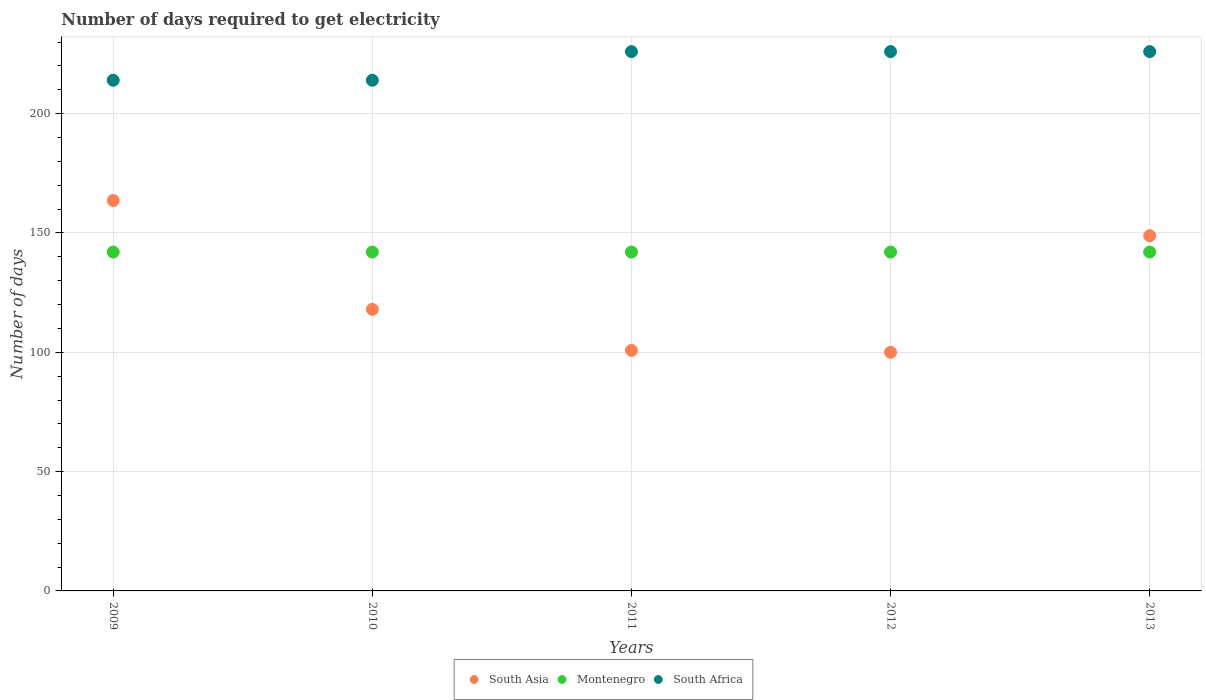How many different coloured dotlines are there?
Your response must be concise. 3. What is the number of days required to get electricity in in South Africa in 2011?
Give a very brief answer. 226. Across all years, what is the maximum number of days required to get electricity in in South Asia?
Offer a terse response. 163.6. Across all years, what is the minimum number of days required to get electricity in in South Asia?
Your answer should be compact. 100. In which year was the number of days required to get electricity in in Montenegro minimum?
Ensure brevity in your answer.  2009. What is the total number of days required to get electricity in in Montenegro in the graph?
Provide a succinct answer. 710. What is the difference between the number of days required to get electricity in in South Africa in 2011 and the number of days required to get electricity in in Montenegro in 2010?
Provide a succinct answer. 84. What is the average number of days required to get electricity in in South Asia per year?
Provide a succinct answer. 126.25. In the year 2012, what is the difference between the number of days required to get electricity in in South Africa and number of days required to get electricity in in Montenegro?
Offer a very short reply. 84. In how many years, is the number of days required to get electricity in in Montenegro greater than 150 days?
Ensure brevity in your answer.  0. What is the ratio of the number of days required to get electricity in in South Asia in 2009 to that in 2012?
Your answer should be compact. 1.64. Is the difference between the number of days required to get electricity in in South Africa in 2010 and 2012 greater than the difference between the number of days required to get electricity in in Montenegro in 2010 and 2012?
Offer a terse response. No. What is the difference between the highest and the lowest number of days required to get electricity in in South Asia?
Make the answer very short. 63.6. Is the sum of the number of days required to get electricity in in South Africa in 2009 and 2013 greater than the maximum number of days required to get electricity in in Montenegro across all years?
Make the answer very short. Yes. Is it the case that in every year, the sum of the number of days required to get electricity in in South Asia and number of days required to get electricity in in South Africa  is greater than the number of days required to get electricity in in Montenegro?
Offer a terse response. Yes. Is the number of days required to get electricity in in South Asia strictly greater than the number of days required to get electricity in in South Africa over the years?
Offer a very short reply. No. Is the number of days required to get electricity in in Montenegro strictly less than the number of days required to get electricity in in South Asia over the years?
Provide a succinct answer. No. How many dotlines are there?
Offer a terse response. 3. What is the difference between two consecutive major ticks on the Y-axis?
Provide a short and direct response. 50. Does the graph contain any zero values?
Ensure brevity in your answer.  No. Does the graph contain grids?
Ensure brevity in your answer.  Yes. How many legend labels are there?
Offer a terse response. 3. What is the title of the graph?
Give a very brief answer. Number of days required to get electricity. What is the label or title of the Y-axis?
Your response must be concise. Number of days. What is the Number of days of South Asia in 2009?
Make the answer very short. 163.6. What is the Number of days in Montenegro in 2009?
Provide a short and direct response. 142. What is the Number of days in South Africa in 2009?
Your answer should be compact. 214. What is the Number of days in South Asia in 2010?
Your answer should be compact. 118. What is the Number of days of Montenegro in 2010?
Your answer should be compact. 142. What is the Number of days of South Africa in 2010?
Give a very brief answer. 214. What is the Number of days in South Asia in 2011?
Provide a short and direct response. 100.8. What is the Number of days of Montenegro in 2011?
Provide a succinct answer. 142. What is the Number of days of South Africa in 2011?
Offer a terse response. 226. What is the Number of days in Montenegro in 2012?
Offer a terse response. 142. What is the Number of days in South Africa in 2012?
Keep it short and to the point. 226. What is the Number of days of South Asia in 2013?
Make the answer very short. 148.86. What is the Number of days in Montenegro in 2013?
Provide a short and direct response. 142. What is the Number of days of South Africa in 2013?
Your response must be concise. 226. Across all years, what is the maximum Number of days in South Asia?
Provide a succinct answer. 163.6. Across all years, what is the maximum Number of days in Montenegro?
Make the answer very short. 142. Across all years, what is the maximum Number of days in South Africa?
Give a very brief answer. 226. Across all years, what is the minimum Number of days of Montenegro?
Offer a very short reply. 142. Across all years, what is the minimum Number of days in South Africa?
Offer a terse response. 214. What is the total Number of days of South Asia in the graph?
Offer a terse response. 631.26. What is the total Number of days in Montenegro in the graph?
Your answer should be compact. 710. What is the total Number of days of South Africa in the graph?
Make the answer very short. 1106. What is the difference between the Number of days in South Asia in 2009 and that in 2010?
Ensure brevity in your answer.  45.6. What is the difference between the Number of days of South Asia in 2009 and that in 2011?
Your response must be concise. 62.8. What is the difference between the Number of days in Montenegro in 2009 and that in 2011?
Make the answer very short. 0. What is the difference between the Number of days of South Africa in 2009 and that in 2011?
Make the answer very short. -12. What is the difference between the Number of days in South Asia in 2009 and that in 2012?
Give a very brief answer. 63.6. What is the difference between the Number of days of South Africa in 2009 and that in 2012?
Offer a very short reply. -12. What is the difference between the Number of days in South Asia in 2009 and that in 2013?
Offer a terse response. 14.74. What is the difference between the Number of days in Montenegro in 2009 and that in 2013?
Your answer should be very brief. 0. What is the difference between the Number of days in South Africa in 2009 and that in 2013?
Your answer should be compact. -12. What is the difference between the Number of days of South Asia in 2010 and that in 2011?
Provide a short and direct response. 17.2. What is the difference between the Number of days of Montenegro in 2010 and that in 2011?
Keep it short and to the point. 0. What is the difference between the Number of days in South Africa in 2010 and that in 2011?
Ensure brevity in your answer.  -12. What is the difference between the Number of days in South Asia in 2010 and that in 2012?
Provide a short and direct response. 18. What is the difference between the Number of days of South Asia in 2010 and that in 2013?
Provide a succinct answer. -30.86. What is the difference between the Number of days of Montenegro in 2010 and that in 2013?
Make the answer very short. 0. What is the difference between the Number of days of South Asia in 2011 and that in 2012?
Give a very brief answer. 0.8. What is the difference between the Number of days in Montenegro in 2011 and that in 2012?
Offer a very short reply. 0. What is the difference between the Number of days in South Africa in 2011 and that in 2012?
Ensure brevity in your answer.  0. What is the difference between the Number of days of South Asia in 2011 and that in 2013?
Ensure brevity in your answer.  -48.06. What is the difference between the Number of days of South Asia in 2012 and that in 2013?
Make the answer very short. -48.86. What is the difference between the Number of days of South Asia in 2009 and the Number of days of Montenegro in 2010?
Your answer should be compact. 21.6. What is the difference between the Number of days of South Asia in 2009 and the Number of days of South Africa in 2010?
Your answer should be very brief. -50.4. What is the difference between the Number of days of Montenegro in 2009 and the Number of days of South Africa in 2010?
Your response must be concise. -72. What is the difference between the Number of days of South Asia in 2009 and the Number of days of Montenegro in 2011?
Offer a terse response. 21.6. What is the difference between the Number of days of South Asia in 2009 and the Number of days of South Africa in 2011?
Keep it short and to the point. -62.4. What is the difference between the Number of days of Montenegro in 2009 and the Number of days of South Africa in 2011?
Your answer should be very brief. -84. What is the difference between the Number of days of South Asia in 2009 and the Number of days of Montenegro in 2012?
Provide a short and direct response. 21.6. What is the difference between the Number of days in South Asia in 2009 and the Number of days in South Africa in 2012?
Give a very brief answer. -62.4. What is the difference between the Number of days in Montenegro in 2009 and the Number of days in South Africa in 2012?
Your response must be concise. -84. What is the difference between the Number of days in South Asia in 2009 and the Number of days in Montenegro in 2013?
Offer a very short reply. 21.6. What is the difference between the Number of days in South Asia in 2009 and the Number of days in South Africa in 2013?
Your response must be concise. -62.4. What is the difference between the Number of days of Montenegro in 2009 and the Number of days of South Africa in 2013?
Provide a succinct answer. -84. What is the difference between the Number of days in South Asia in 2010 and the Number of days in South Africa in 2011?
Offer a very short reply. -108. What is the difference between the Number of days in Montenegro in 2010 and the Number of days in South Africa in 2011?
Offer a terse response. -84. What is the difference between the Number of days in South Asia in 2010 and the Number of days in Montenegro in 2012?
Provide a short and direct response. -24. What is the difference between the Number of days in South Asia in 2010 and the Number of days in South Africa in 2012?
Provide a succinct answer. -108. What is the difference between the Number of days of Montenegro in 2010 and the Number of days of South Africa in 2012?
Your answer should be very brief. -84. What is the difference between the Number of days of South Asia in 2010 and the Number of days of South Africa in 2013?
Offer a terse response. -108. What is the difference between the Number of days in Montenegro in 2010 and the Number of days in South Africa in 2013?
Make the answer very short. -84. What is the difference between the Number of days of South Asia in 2011 and the Number of days of Montenegro in 2012?
Your answer should be very brief. -41.2. What is the difference between the Number of days in South Asia in 2011 and the Number of days in South Africa in 2012?
Make the answer very short. -125.2. What is the difference between the Number of days of Montenegro in 2011 and the Number of days of South Africa in 2012?
Keep it short and to the point. -84. What is the difference between the Number of days of South Asia in 2011 and the Number of days of Montenegro in 2013?
Provide a succinct answer. -41.2. What is the difference between the Number of days of South Asia in 2011 and the Number of days of South Africa in 2013?
Provide a short and direct response. -125.2. What is the difference between the Number of days in Montenegro in 2011 and the Number of days in South Africa in 2013?
Ensure brevity in your answer.  -84. What is the difference between the Number of days of South Asia in 2012 and the Number of days of Montenegro in 2013?
Offer a terse response. -42. What is the difference between the Number of days in South Asia in 2012 and the Number of days in South Africa in 2013?
Your response must be concise. -126. What is the difference between the Number of days of Montenegro in 2012 and the Number of days of South Africa in 2013?
Give a very brief answer. -84. What is the average Number of days in South Asia per year?
Your answer should be compact. 126.25. What is the average Number of days in Montenegro per year?
Ensure brevity in your answer.  142. What is the average Number of days in South Africa per year?
Your answer should be very brief. 221.2. In the year 2009, what is the difference between the Number of days of South Asia and Number of days of Montenegro?
Make the answer very short. 21.6. In the year 2009, what is the difference between the Number of days of South Asia and Number of days of South Africa?
Your response must be concise. -50.4. In the year 2009, what is the difference between the Number of days of Montenegro and Number of days of South Africa?
Your answer should be compact. -72. In the year 2010, what is the difference between the Number of days of South Asia and Number of days of South Africa?
Provide a short and direct response. -96. In the year 2010, what is the difference between the Number of days of Montenegro and Number of days of South Africa?
Provide a succinct answer. -72. In the year 2011, what is the difference between the Number of days of South Asia and Number of days of Montenegro?
Provide a succinct answer. -41.2. In the year 2011, what is the difference between the Number of days of South Asia and Number of days of South Africa?
Offer a very short reply. -125.2. In the year 2011, what is the difference between the Number of days of Montenegro and Number of days of South Africa?
Your response must be concise. -84. In the year 2012, what is the difference between the Number of days of South Asia and Number of days of Montenegro?
Make the answer very short. -42. In the year 2012, what is the difference between the Number of days of South Asia and Number of days of South Africa?
Your answer should be very brief. -126. In the year 2012, what is the difference between the Number of days of Montenegro and Number of days of South Africa?
Ensure brevity in your answer.  -84. In the year 2013, what is the difference between the Number of days in South Asia and Number of days in Montenegro?
Make the answer very short. 6.86. In the year 2013, what is the difference between the Number of days in South Asia and Number of days in South Africa?
Your answer should be compact. -77.14. In the year 2013, what is the difference between the Number of days in Montenegro and Number of days in South Africa?
Ensure brevity in your answer.  -84. What is the ratio of the Number of days of South Asia in 2009 to that in 2010?
Provide a short and direct response. 1.39. What is the ratio of the Number of days of South Asia in 2009 to that in 2011?
Keep it short and to the point. 1.62. What is the ratio of the Number of days of Montenegro in 2009 to that in 2011?
Ensure brevity in your answer.  1. What is the ratio of the Number of days in South Africa in 2009 to that in 2011?
Your answer should be compact. 0.95. What is the ratio of the Number of days in South Asia in 2009 to that in 2012?
Your answer should be very brief. 1.64. What is the ratio of the Number of days in South Africa in 2009 to that in 2012?
Offer a very short reply. 0.95. What is the ratio of the Number of days of South Asia in 2009 to that in 2013?
Ensure brevity in your answer.  1.1. What is the ratio of the Number of days of Montenegro in 2009 to that in 2013?
Offer a terse response. 1. What is the ratio of the Number of days in South Africa in 2009 to that in 2013?
Ensure brevity in your answer.  0.95. What is the ratio of the Number of days of South Asia in 2010 to that in 2011?
Your answer should be very brief. 1.17. What is the ratio of the Number of days in Montenegro in 2010 to that in 2011?
Give a very brief answer. 1. What is the ratio of the Number of days of South Africa in 2010 to that in 2011?
Offer a very short reply. 0.95. What is the ratio of the Number of days in South Asia in 2010 to that in 2012?
Your answer should be compact. 1.18. What is the ratio of the Number of days in Montenegro in 2010 to that in 2012?
Your response must be concise. 1. What is the ratio of the Number of days of South Africa in 2010 to that in 2012?
Your response must be concise. 0.95. What is the ratio of the Number of days in South Asia in 2010 to that in 2013?
Offer a very short reply. 0.79. What is the ratio of the Number of days in South Africa in 2010 to that in 2013?
Provide a succinct answer. 0.95. What is the ratio of the Number of days of South Asia in 2011 to that in 2012?
Ensure brevity in your answer.  1.01. What is the ratio of the Number of days in Montenegro in 2011 to that in 2012?
Your answer should be very brief. 1. What is the ratio of the Number of days of South Africa in 2011 to that in 2012?
Your response must be concise. 1. What is the ratio of the Number of days of South Asia in 2011 to that in 2013?
Your answer should be compact. 0.68. What is the ratio of the Number of days of South Asia in 2012 to that in 2013?
Ensure brevity in your answer.  0.67. What is the ratio of the Number of days of South Africa in 2012 to that in 2013?
Your answer should be very brief. 1. What is the difference between the highest and the second highest Number of days in South Asia?
Ensure brevity in your answer.  14.74. What is the difference between the highest and the second highest Number of days of South Africa?
Keep it short and to the point. 0. What is the difference between the highest and the lowest Number of days in South Asia?
Your answer should be compact. 63.6. What is the difference between the highest and the lowest Number of days in South Africa?
Provide a short and direct response. 12. 